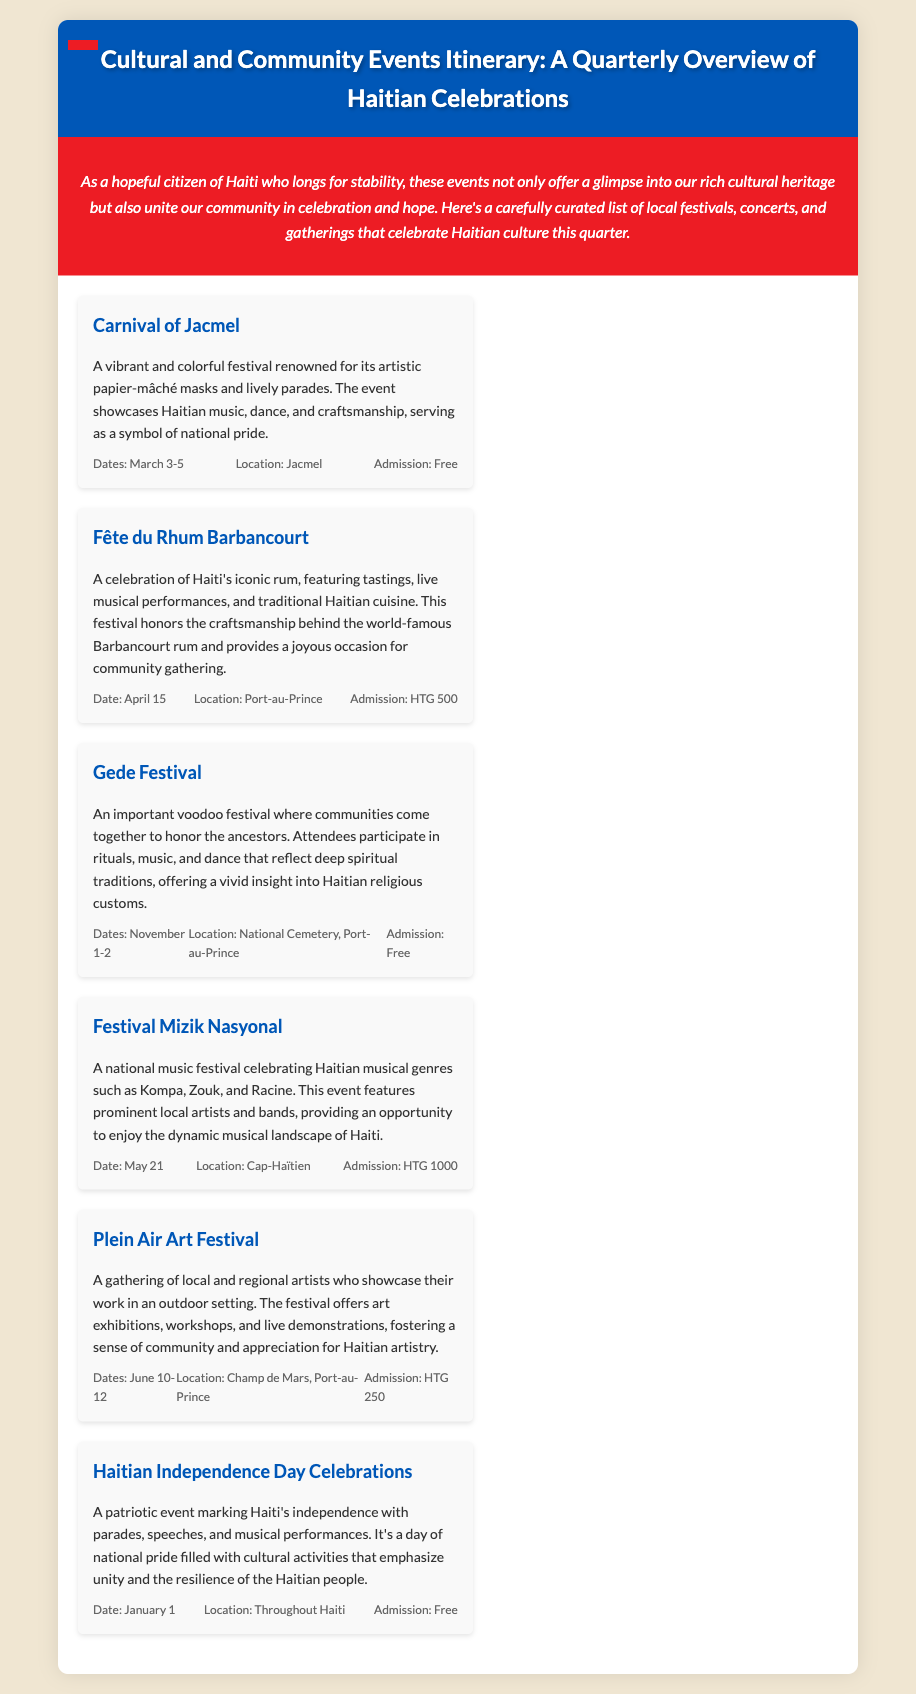What is the date of the Carnival of Jacmel? The date for the Carnival of Jacmel is mentioned in the document as March 3-5.
Answer: March 3-5 Where is the Fête du Rhum Barbancourt held? The location for the Fête du Rhum Barbancourt is specified in the document as Port-au-Prince.
Answer: Port-au-Prince What kind of festival is the Gede Festival? The Gede Festival is described as an important voodoo festival in the document.
Answer: Voodoo What is the admission fee for the Festival Mizik Nasyonal? The document states that the admission fee for the Festival Mizik Nasyonal is HTG 1000.
Answer: HTG 1000 What cultural aspect does the Plein Air Art Festival emphasize? The document mentions that the Plein Air Art Festival fosters appreciation for Haitian artistry.
Answer: Haitian artistry Which event celebrates Haiti's independence? The event that celebrates Haiti's independence is mentioned as Haitian Independence Day Celebrations.
Answer: Haitian Independence Day Celebrations How many days does the Plein Air Art Festival last? The document states that the Plein Air Art Festival lasts for three days, from June 10-12.
Answer: Three days What is highlighted in the Fête du Rhum Barbancourt? The Fête du Rhum Barbancourt highlights the craftsmanship behind Barbancourt rum.
Answer: Craftsmanship behind Barbancourt rum What type of events does the itinerary showcase? The itinerary showcases local festivals, concerts, and community gatherings.
Answer: Local festivals, concerts, and community gatherings 